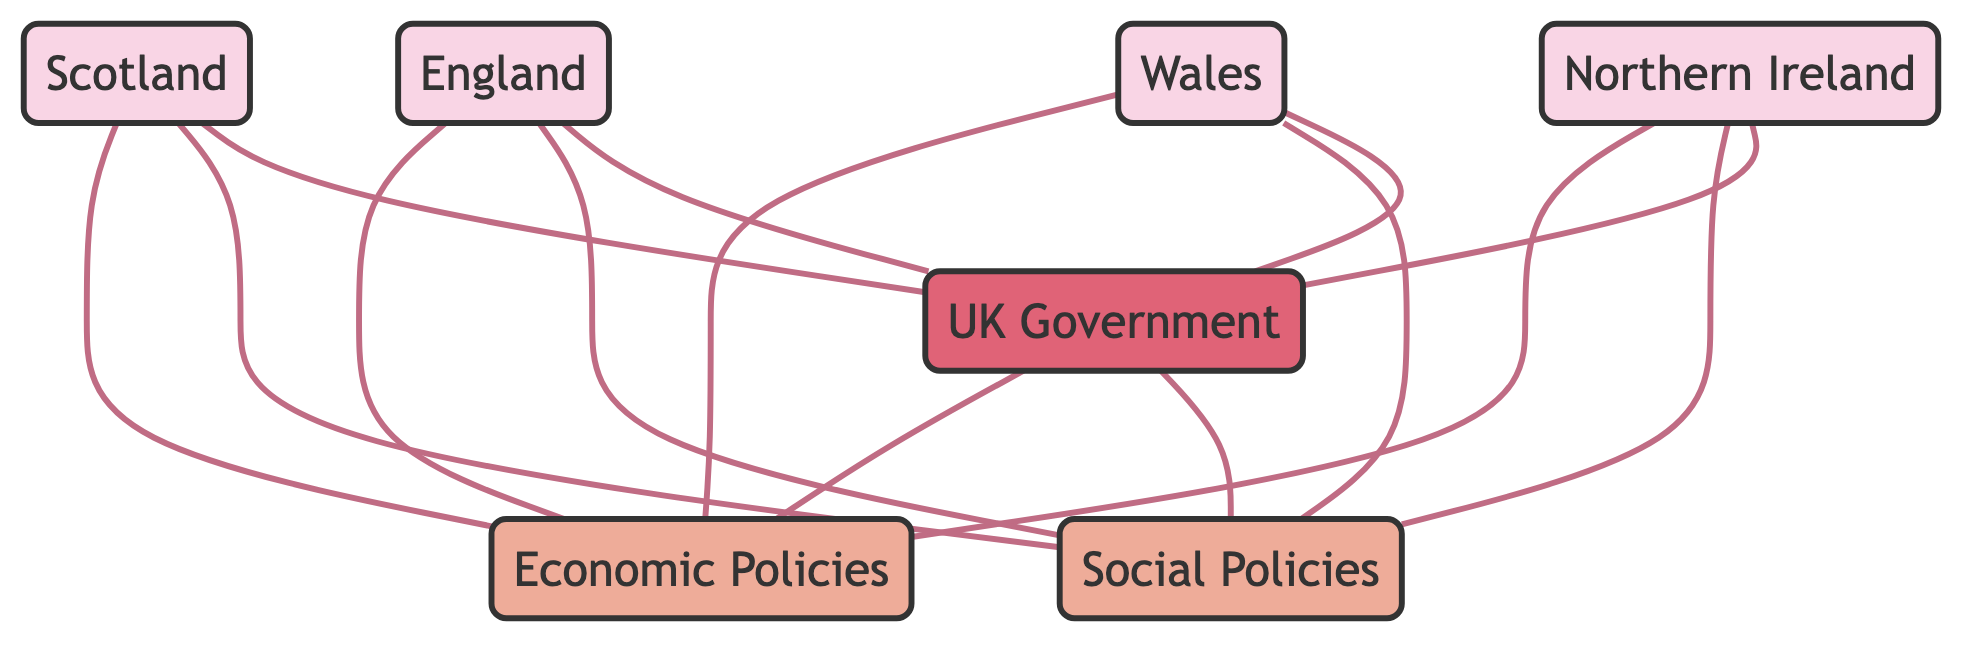What are the total number of nodes in the diagram? The diagram has a total of 7 nodes, which consist of 4 regions (Scotland, England, Wales, Northern Ireland) and 3 policy/government entities (Economic Policies, Social Policies, UK Government).
Answer: 7 How many relationships does Scotland have in the diagram? Scotland has 4 relationships in the diagram: it aligns on Economic Policies, aligns on Social Policies, works with UK Government, and also connects to Economic Policies through the UK Government.
Answer: 4 What type of policies do all regions align on? All regions align on both Economic Policies and Social Policies as indicated by the edges connecting Scotland, England, Wales, and Northern Ireland to these policy nodes.
Answer: Economic Policies and Social Policies Which node does the UK Government set policies for? The UK Government sets policies for both Economic Policies and Social Policies as denoted by the edges from the UK Government to each policy node in the diagram.
Answer: Economic Policies and Social Policies How many regions work with the UK Government? All four regions (Scotland, England, Wales, Northern Ireland) work with the UK Government, as each of these nodes has an edge connecting it to the UK Government node.
Answer: 4 Which policy node has the greatest number of connections? Both Economic Policies and Social Policies have 4 connections each, as all regions connect to both policy nodes. However, if considered as unique connections, then each of them has the same number.
Answer: Economic Policies and Social Policies What do the edges between the regions and policy nodes indicate? The edges indicate that the regions align on the respective policies, showing a collaborative relationship between each region and the policies represented in the diagram.
Answer: Aligns on How many edges represent the interactions of the regions with the UK Government? There are 4 edges representing the interactions of the regions with the UK Government, as each of the four regions has a direct link (works with) to the UK Government node.
Answer: 4 